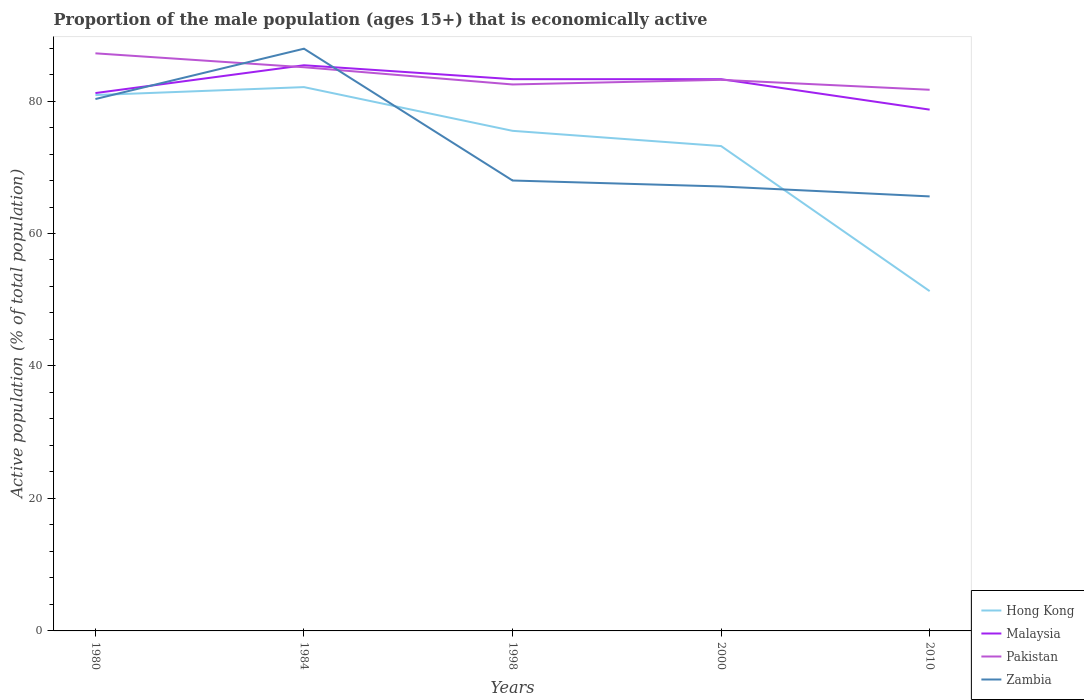How many different coloured lines are there?
Provide a succinct answer. 4. Does the line corresponding to Malaysia intersect with the line corresponding to Hong Kong?
Your answer should be compact. No. Is the number of lines equal to the number of legend labels?
Ensure brevity in your answer.  Yes. Across all years, what is the maximum proportion of the male population that is economically active in Zambia?
Provide a succinct answer. 65.6. What is the total proportion of the male population that is economically active in Zambia in the graph?
Your response must be concise. 2.4. What is the difference between the highest and the second highest proportion of the male population that is economically active in Malaysia?
Offer a very short reply. 6.7. Is the proportion of the male population that is economically active in Pakistan strictly greater than the proportion of the male population that is economically active in Malaysia over the years?
Offer a terse response. No. How many lines are there?
Provide a short and direct response. 4. How many years are there in the graph?
Provide a short and direct response. 5. Are the values on the major ticks of Y-axis written in scientific E-notation?
Provide a short and direct response. No. Does the graph contain any zero values?
Ensure brevity in your answer.  No. Does the graph contain grids?
Give a very brief answer. No. Where does the legend appear in the graph?
Offer a very short reply. Bottom right. How are the legend labels stacked?
Ensure brevity in your answer.  Vertical. What is the title of the graph?
Keep it short and to the point. Proportion of the male population (ages 15+) that is economically active. Does "Nepal" appear as one of the legend labels in the graph?
Make the answer very short. No. What is the label or title of the Y-axis?
Offer a terse response. Active population (% of total population). What is the Active population (% of total population) of Hong Kong in 1980?
Your response must be concise. 80.9. What is the Active population (% of total population) of Malaysia in 1980?
Give a very brief answer. 81.2. What is the Active population (% of total population) of Pakistan in 1980?
Offer a very short reply. 87.2. What is the Active population (% of total population) of Zambia in 1980?
Your answer should be very brief. 80.3. What is the Active population (% of total population) of Hong Kong in 1984?
Provide a succinct answer. 82.1. What is the Active population (% of total population) in Malaysia in 1984?
Provide a short and direct response. 85.4. What is the Active population (% of total population) of Pakistan in 1984?
Keep it short and to the point. 85.1. What is the Active population (% of total population) in Zambia in 1984?
Give a very brief answer. 87.9. What is the Active population (% of total population) in Hong Kong in 1998?
Offer a terse response. 75.5. What is the Active population (% of total population) in Malaysia in 1998?
Your answer should be very brief. 83.3. What is the Active population (% of total population) of Pakistan in 1998?
Make the answer very short. 82.5. What is the Active population (% of total population) in Hong Kong in 2000?
Keep it short and to the point. 73.2. What is the Active population (% of total population) in Malaysia in 2000?
Your response must be concise. 83.3. What is the Active population (% of total population) in Pakistan in 2000?
Offer a very short reply. 83.2. What is the Active population (% of total population) of Zambia in 2000?
Your answer should be compact. 67.1. What is the Active population (% of total population) of Hong Kong in 2010?
Your response must be concise. 51.3. What is the Active population (% of total population) in Malaysia in 2010?
Keep it short and to the point. 78.7. What is the Active population (% of total population) of Pakistan in 2010?
Offer a terse response. 81.7. What is the Active population (% of total population) in Zambia in 2010?
Your answer should be very brief. 65.6. Across all years, what is the maximum Active population (% of total population) in Hong Kong?
Provide a succinct answer. 82.1. Across all years, what is the maximum Active population (% of total population) in Malaysia?
Make the answer very short. 85.4. Across all years, what is the maximum Active population (% of total population) of Pakistan?
Keep it short and to the point. 87.2. Across all years, what is the maximum Active population (% of total population) in Zambia?
Your answer should be very brief. 87.9. Across all years, what is the minimum Active population (% of total population) of Hong Kong?
Ensure brevity in your answer.  51.3. Across all years, what is the minimum Active population (% of total population) in Malaysia?
Ensure brevity in your answer.  78.7. Across all years, what is the minimum Active population (% of total population) of Pakistan?
Your answer should be compact. 81.7. Across all years, what is the minimum Active population (% of total population) in Zambia?
Your response must be concise. 65.6. What is the total Active population (% of total population) in Hong Kong in the graph?
Ensure brevity in your answer.  363. What is the total Active population (% of total population) of Malaysia in the graph?
Keep it short and to the point. 411.9. What is the total Active population (% of total population) of Pakistan in the graph?
Ensure brevity in your answer.  419.7. What is the total Active population (% of total population) in Zambia in the graph?
Make the answer very short. 368.9. What is the difference between the Active population (% of total population) in Hong Kong in 1980 and that in 1984?
Your answer should be compact. -1.2. What is the difference between the Active population (% of total population) of Malaysia in 1980 and that in 1984?
Give a very brief answer. -4.2. What is the difference between the Active population (% of total population) in Zambia in 1980 and that in 1984?
Give a very brief answer. -7.6. What is the difference between the Active population (% of total population) of Hong Kong in 1980 and that in 1998?
Offer a terse response. 5.4. What is the difference between the Active population (% of total population) in Malaysia in 1980 and that in 1998?
Ensure brevity in your answer.  -2.1. What is the difference between the Active population (% of total population) in Pakistan in 1980 and that in 1998?
Provide a succinct answer. 4.7. What is the difference between the Active population (% of total population) in Hong Kong in 1980 and that in 2000?
Make the answer very short. 7.7. What is the difference between the Active population (% of total population) in Pakistan in 1980 and that in 2000?
Your response must be concise. 4. What is the difference between the Active population (% of total population) in Hong Kong in 1980 and that in 2010?
Your answer should be very brief. 29.6. What is the difference between the Active population (% of total population) in Pakistan in 1980 and that in 2010?
Provide a succinct answer. 5.5. What is the difference between the Active population (% of total population) of Hong Kong in 1984 and that in 2000?
Make the answer very short. 8.9. What is the difference between the Active population (% of total population) in Malaysia in 1984 and that in 2000?
Keep it short and to the point. 2.1. What is the difference between the Active population (% of total population) in Zambia in 1984 and that in 2000?
Give a very brief answer. 20.8. What is the difference between the Active population (% of total population) of Hong Kong in 1984 and that in 2010?
Give a very brief answer. 30.8. What is the difference between the Active population (% of total population) in Malaysia in 1984 and that in 2010?
Offer a very short reply. 6.7. What is the difference between the Active population (% of total population) of Pakistan in 1984 and that in 2010?
Provide a short and direct response. 3.4. What is the difference between the Active population (% of total population) in Zambia in 1984 and that in 2010?
Make the answer very short. 22.3. What is the difference between the Active population (% of total population) of Hong Kong in 1998 and that in 2000?
Make the answer very short. 2.3. What is the difference between the Active population (% of total population) of Malaysia in 1998 and that in 2000?
Provide a short and direct response. 0. What is the difference between the Active population (% of total population) of Hong Kong in 1998 and that in 2010?
Provide a short and direct response. 24.2. What is the difference between the Active population (% of total population) of Pakistan in 1998 and that in 2010?
Provide a succinct answer. 0.8. What is the difference between the Active population (% of total population) of Hong Kong in 2000 and that in 2010?
Offer a terse response. 21.9. What is the difference between the Active population (% of total population) of Pakistan in 2000 and that in 2010?
Make the answer very short. 1.5. What is the difference between the Active population (% of total population) in Hong Kong in 1980 and the Active population (% of total population) in Zambia in 1984?
Provide a succinct answer. -7. What is the difference between the Active population (% of total population) of Malaysia in 1980 and the Active population (% of total population) of Pakistan in 1984?
Your answer should be compact. -3.9. What is the difference between the Active population (% of total population) of Malaysia in 1980 and the Active population (% of total population) of Zambia in 1984?
Provide a succinct answer. -6.7. What is the difference between the Active population (% of total population) in Hong Kong in 1980 and the Active population (% of total population) in Pakistan in 1998?
Give a very brief answer. -1.6. What is the difference between the Active population (% of total population) of Hong Kong in 1980 and the Active population (% of total population) of Zambia in 1998?
Offer a very short reply. 12.9. What is the difference between the Active population (% of total population) of Malaysia in 1980 and the Active population (% of total population) of Zambia in 1998?
Offer a very short reply. 13.2. What is the difference between the Active population (% of total population) of Pakistan in 1980 and the Active population (% of total population) of Zambia in 1998?
Your response must be concise. 19.2. What is the difference between the Active population (% of total population) in Malaysia in 1980 and the Active population (% of total population) in Pakistan in 2000?
Your answer should be compact. -2. What is the difference between the Active population (% of total population) of Pakistan in 1980 and the Active population (% of total population) of Zambia in 2000?
Ensure brevity in your answer.  20.1. What is the difference between the Active population (% of total population) in Hong Kong in 1980 and the Active population (% of total population) in Malaysia in 2010?
Provide a short and direct response. 2.2. What is the difference between the Active population (% of total population) of Malaysia in 1980 and the Active population (% of total population) of Zambia in 2010?
Keep it short and to the point. 15.6. What is the difference between the Active population (% of total population) in Pakistan in 1980 and the Active population (% of total population) in Zambia in 2010?
Keep it short and to the point. 21.6. What is the difference between the Active population (% of total population) of Hong Kong in 1984 and the Active population (% of total population) of Pakistan in 1998?
Offer a terse response. -0.4. What is the difference between the Active population (% of total population) in Malaysia in 1984 and the Active population (% of total population) in Pakistan in 1998?
Make the answer very short. 2.9. What is the difference between the Active population (% of total population) in Malaysia in 1984 and the Active population (% of total population) in Zambia in 1998?
Give a very brief answer. 17.4. What is the difference between the Active population (% of total population) in Pakistan in 1984 and the Active population (% of total population) in Zambia in 1998?
Your answer should be very brief. 17.1. What is the difference between the Active population (% of total population) of Hong Kong in 1984 and the Active population (% of total population) of Pakistan in 2000?
Keep it short and to the point. -1.1. What is the difference between the Active population (% of total population) in Hong Kong in 1984 and the Active population (% of total population) in Zambia in 2000?
Give a very brief answer. 15. What is the difference between the Active population (% of total population) in Hong Kong in 1984 and the Active population (% of total population) in Malaysia in 2010?
Provide a succinct answer. 3.4. What is the difference between the Active population (% of total population) of Hong Kong in 1984 and the Active population (% of total population) of Pakistan in 2010?
Your answer should be compact. 0.4. What is the difference between the Active population (% of total population) of Malaysia in 1984 and the Active population (% of total population) of Pakistan in 2010?
Your response must be concise. 3.7. What is the difference between the Active population (% of total population) of Malaysia in 1984 and the Active population (% of total population) of Zambia in 2010?
Keep it short and to the point. 19.8. What is the difference between the Active population (% of total population) of Hong Kong in 1998 and the Active population (% of total population) of Zambia in 2000?
Keep it short and to the point. 8.4. What is the difference between the Active population (% of total population) of Malaysia in 1998 and the Active population (% of total population) of Pakistan in 2000?
Offer a terse response. 0.1. What is the difference between the Active population (% of total population) of Pakistan in 1998 and the Active population (% of total population) of Zambia in 2000?
Provide a short and direct response. 15.4. What is the difference between the Active population (% of total population) in Hong Kong in 1998 and the Active population (% of total population) in Malaysia in 2010?
Offer a terse response. -3.2. What is the difference between the Active population (% of total population) in Hong Kong in 1998 and the Active population (% of total population) in Zambia in 2010?
Give a very brief answer. 9.9. What is the difference between the Active population (% of total population) in Hong Kong in 2000 and the Active population (% of total population) in Pakistan in 2010?
Your response must be concise. -8.5. What is the average Active population (% of total population) of Hong Kong per year?
Give a very brief answer. 72.6. What is the average Active population (% of total population) in Malaysia per year?
Make the answer very short. 82.38. What is the average Active population (% of total population) of Pakistan per year?
Your answer should be compact. 83.94. What is the average Active population (% of total population) of Zambia per year?
Give a very brief answer. 73.78. In the year 1980, what is the difference between the Active population (% of total population) of Hong Kong and Active population (% of total population) of Pakistan?
Give a very brief answer. -6.3. In the year 1980, what is the difference between the Active population (% of total population) in Malaysia and Active population (% of total population) in Pakistan?
Provide a succinct answer. -6. In the year 1980, what is the difference between the Active population (% of total population) of Malaysia and Active population (% of total population) of Zambia?
Your answer should be compact. 0.9. In the year 1980, what is the difference between the Active population (% of total population) in Pakistan and Active population (% of total population) in Zambia?
Provide a short and direct response. 6.9. In the year 1984, what is the difference between the Active population (% of total population) in Hong Kong and Active population (% of total population) in Malaysia?
Offer a very short reply. -3.3. In the year 1984, what is the difference between the Active population (% of total population) in Hong Kong and Active population (% of total population) in Pakistan?
Give a very brief answer. -3. In the year 1984, what is the difference between the Active population (% of total population) in Hong Kong and Active population (% of total population) in Zambia?
Keep it short and to the point. -5.8. In the year 1984, what is the difference between the Active population (% of total population) in Malaysia and Active population (% of total population) in Pakistan?
Your answer should be very brief. 0.3. In the year 1984, what is the difference between the Active population (% of total population) in Malaysia and Active population (% of total population) in Zambia?
Provide a succinct answer. -2.5. In the year 1998, what is the difference between the Active population (% of total population) in Hong Kong and Active population (% of total population) in Pakistan?
Your answer should be compact. -7. In the year 1998, what is the difference between the Active population (% of total population) in Malaysia and Active population (% of total population) in Pakistan?
Your answer should be very brief. 0.8. In the year 2000, what is the difference between the Active population (% of total population) of Hong Kong and Active population (% of total population) of Malaysia?
Provide a succinct answer. -10.1. In the year 2000, what is the difference between the Active population (% of total population) of Hong Kong and Active population (% of total population) of Zambia?
Offer a terse response. 6.1. In the year 2000, what is the difference between the Active population (% of total population) in Malaysia and Active population (% of total population) in Zambia?
Offer a very short reply. 16.2. In the year 2010, what is the difference between the Active population (% of total population) in Hong Kong and Active population (% of total population) in Malaysia?
Your answer should be very brief. -27.4. In the year 2010, what is the difference between the Active population (% of total population) of Hong Kong and Active population (% of total population) of Pakistan?
Keep it short and to the point. -30.4. In the year 2010, what is the difference between the Active population (% of total population) of Hong Kong and Active population (% of total population) of Zambia?
Your answer should be compact. -14.3. In the year 2010, what is the difference between the Active population (% of total population) of Malaysia and Active population (% of total population) of Zambia?
Make the answer very short. 13.1. What is the ratio of the Active population (% of total population) of Hong Kong in 1980 to that in 1984?
Offer a very short reply. 0.99. What is the ratio of the Active population (% of total population) in Malaysia in 1980 to that in 1984?
Your answer should be very brief. 0.95. What is the ratio of the Active population (% of total population) in Pakistan in 1980 to that in 1984?
Provide a succinct answer. 1.02. What is the ratio of the Active population (% of total population) in Zambia in 1980 to that in 1984?
Offer a terse response. 0.91. What is the ratio of the Active population (% of total population) of Hong Kong in 1980 to that in 1998?
Provide a short and direct response. 1.07. What is the ratio of the Active population (% of total population) in Malaysia in 1980 to that in 1998?
Ensure brevity in your answer.  0.97. What is the ratio of the Active population (% of total population) of Pakistan in 1980 to that in 1998?
Offer a very short reply. 1.06. What is the ratio of the Active population (% of total population) of Zambia in 1980 to that in 1998?
Your answer should be compact. 1.18. What is the ratio of the Active population (% of total population) of Hong Kong in 1980 to that in 2000?
Your answer should be very brief. 1.11. What is the ratio of the Active population (% of total population) of Malaysia in 1980 to that in 2000?
Your answer should be compact. 0.97. What is the ratio of the Active population (% of total population) of Pakistan in 1980 to that in 2000?
Offer a terse response. 1.05. What is the ratio of the Active population (% of total population) of Zambia in 1980 to that in 2000?
Offer a terse response. 1.2. What is the ratio of the Active population (% of total population) of Hong Kong in 1980 to that in 2010?
Provide a short and direct response. 1.58. What is the ratio of the Active population (% of total population) in Malaysia in 1980 to that in 2010?
Ensure brevity in your answer.  1.03. What is the ratio of the Active population (% of total population) of Pakistan in 1980 to that in 2010?
Your response must be concise. 1.07. What is the ratio of the Active population (% of total population) in Zambia in 1980 to that in 2010?
Your answer should be very brief. 1.22. What is the ratio of the Active population (% of total population) in Hong Kong in 1984 to that in 1998?
Your answer should be compact. 1.09. What is the ratio of the Active population (% of total population) in Malaysia in 1984 to that in 1998?
Make the answer very short. 1.03. What is the ratio of the Active population (% of total population) in Pakistan in 1984 to that in 1998?
Offer a very short reply. 1.03. What is the ratio of the Active population (% of total population) in Zambia in 1984 to that in 1998?
Provide a succinct answer. 1.29. What is the ratio of the Active population (% of total population) in Hong Kong in 1984 to that in 2000?
Offer a very short reply. 1.12. What is the ratio of the Active population (% of total population) of Malaysia in 1984 to that in 2000?
Your response must be concise. 1.03. What is the ratio of the Active population (% of total population) of Pakistan in 1984 to that in 2000?
Offer a terse response. 1.02. What is the ratio of the Active population (% of total population) in Zambia in 1984 to that in 2000?
Keep it short and to the point. 1.31. What is the ratio of the Active population (% of total population) of Hong Kong in 1984 to that in 2010?
Your answer should be compact. 1.6. What is the ratio of the Active population (% of total population) of Malaysia in 1984 to that in 2010?
Offer a very short reply. 1.09. What is the ratio of the Active population (% of total population) of Pakistan in 1984 to that in 2010?
Make the answer very short. 1.04. What is the ratio of the Active population (% of total population) of Zambia in 1984 to that in 2010?
Ensure brevity in your answer.  1.34. What is the ratio of the Active population (% of total population) in Hong Kong in 1998 to that in 2000?
Provide a succinct answer. 1.03. What is the ratio of the Active population (% of total population) of Malaysia in 1998 to that in 2000?
Ensure brevity in your answer.  1. What is the ratio of the Active population (% of total population) of Zambia in 1998 to that in 2000?
Provide a succinct answer. 1.01. What is the ratio of the Active population (% of total population) in Hong Kong in 1998 to that in 2010?
Provide a succinct answer. 1.47. What is the ratio of the Active population (% of total population) of Malaysia in 1998 to that in 2010?
Offer a terse response. 1.06. What is the ratio of the Active population (% of total population) of Pakistan in 1998 to that in 2010?
Your answer should be compact. 1.01. What is the ratio of the Active population (% of total population) of Zambia in 1998 to that in 2010?
Make the answer very short. 1.04. What is the ratio of the Active population (% of total population) in Hong Kong in 2000 to that in 2010?
Make the answer very short. 1.43. What is the ratio of the Active population (% of total population) in Malaysia in 2000 to that in 2010?
Provide a succinct answer. 1.06. What is the ratio of the Active population (% of total population) of Pakistan in 2000 to that in 2010?
Offer a very short reply. 1.02. What is the ratio of the Active population (% of total population) of Zambia in 2000 to that in 2010?
Provide a succinct answer. 1.02. What is the difference between the highest and the second highest Active population (% of total population) of Malaysia?
Your answer should be very brief. 2.1. What is the difference between the highest and the second highest Active population (% of total population) in Pakistan?
Offer a very short reply. 2.1. What is the difference between the highest and the second highest Active population (% of total population) of Zambia?
Provide a short and direct response. 7.6. What is the difference between the highest and the lowest Active population (% of total population) in Hong Kong?
Your response must be concise. 30.8. What is the difference between the highest and the lowest Active population (% of total population) in Malaysia?
Provide a succinct answer. 6.7. What is the difference between the highest and the lowest Active population (% of total population) of Zambia?
Ensure brevity in your answer.  22.3. 